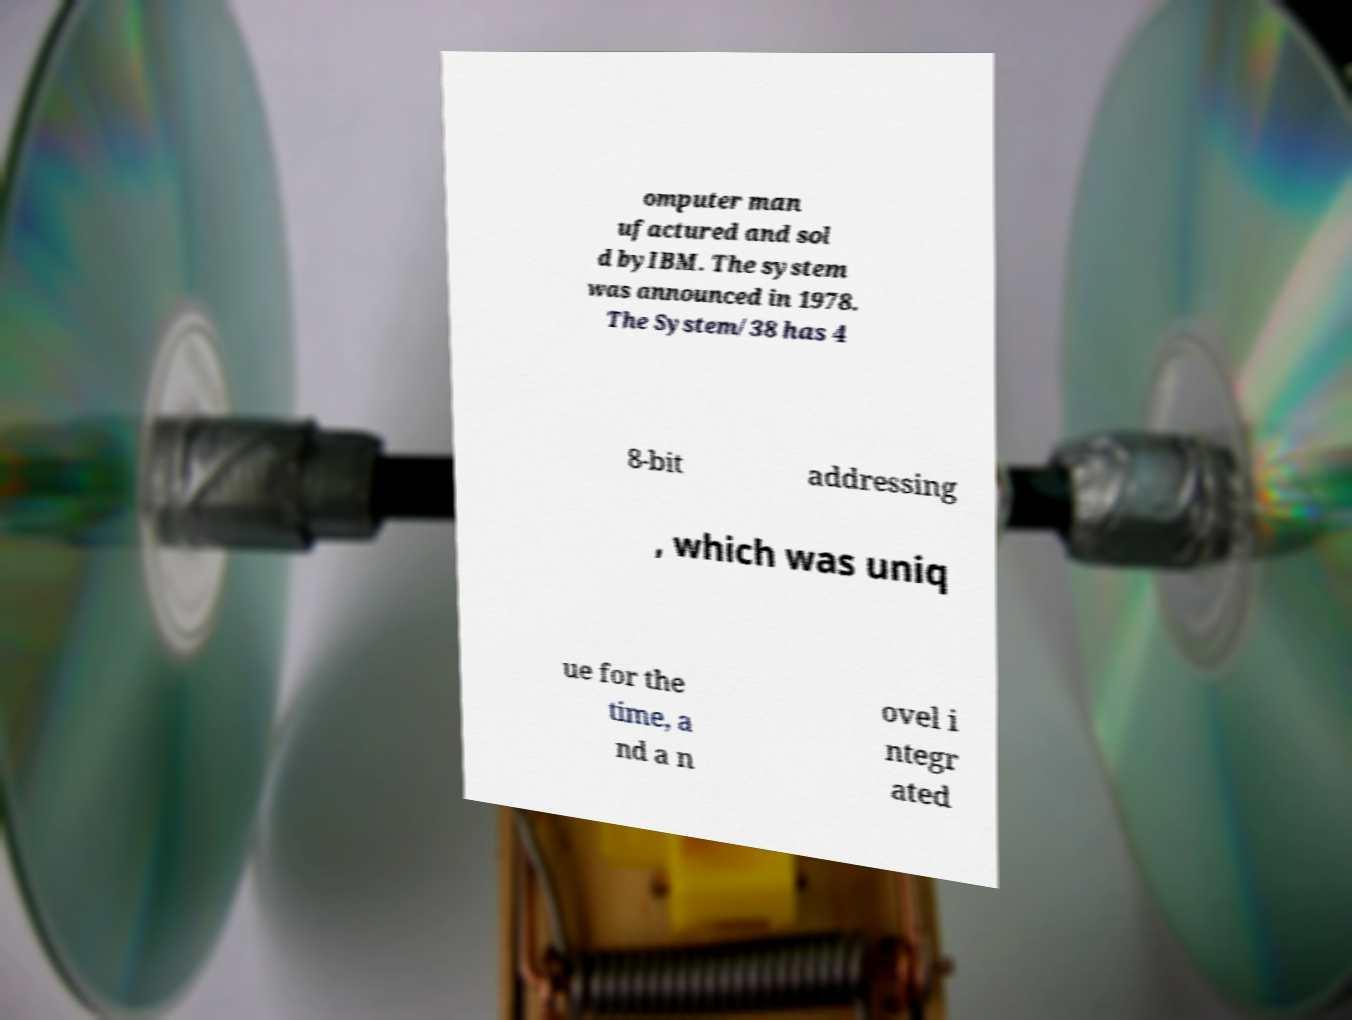Could you extract and type out the text from this image? omputer man ufactured and sol d byIBM. The system was announced in 1978. The System/38 has 4 8-bit addressing , which was uniq ue for the time, a nd a n ovel i ntegr ated 